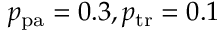<formula> <loc_0><loc_0><loc_500><loc_500>p _ { p a } = 0 . 3 , p _ { t r } = 0 . 1</formula> 